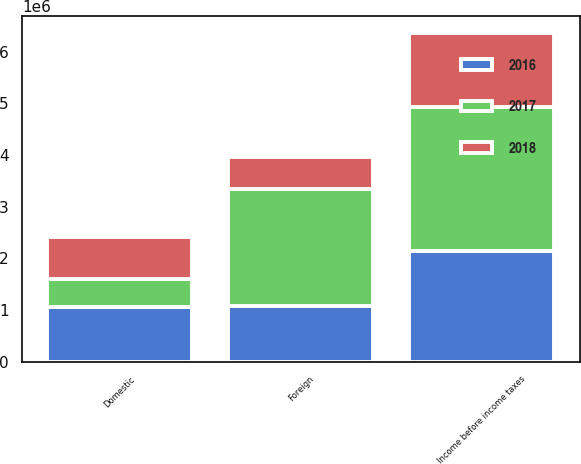Convert chart. <chart><loc_0><loc_0><loc_500><loc_500><stacked_bar_chart><ecel><fcel>Domestic<fcel>Foreign<fcel>Income before income taxes<nl><fcel>2017<fcel>542948<fcel>2.25093e+06<fcel>2.79388e+06<nl><fcel>2016<fcel>1.05616e+06<fcel>1.08148e+06<fcel>2.13764e+06<nl><fcel>2018<fcel>805749<fcel>629389<fcel>1.43514e+06<nl></chart> 